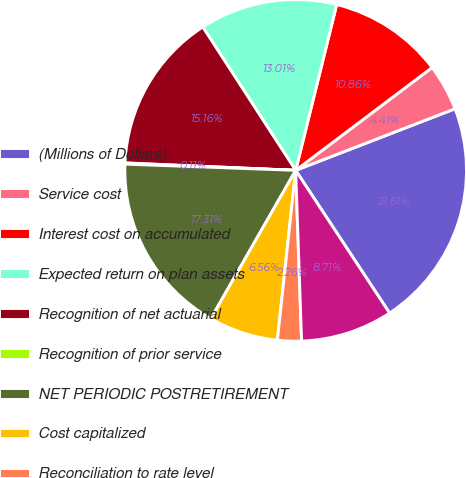Convert chart. <chart><loc_0><loc_0><loc_500><loc_500><pie_chart><fcel>(Millions of Dollars)<fcel>Service cost<fcel>Interest cost on accumulated<fcel>Expected return on plan assets<fcel>Recognition of net actuarial<fcel>Recognition of prior service<fcel>NET PERIODIC POSTRETIREMENT<fcel>Cost capitalized<fcel>Reconciliation to rate level<fcel>Cost charged to operating<nl><fcel>21.61%<fcel>4.41%<fcel>10.86%<fcel>13.01%<fcel>15.16%<fcel>0.11%<fcel>17.31%<fcel>6.56%<fcel>2.26%<fcel>8.71%<nl></chart> 